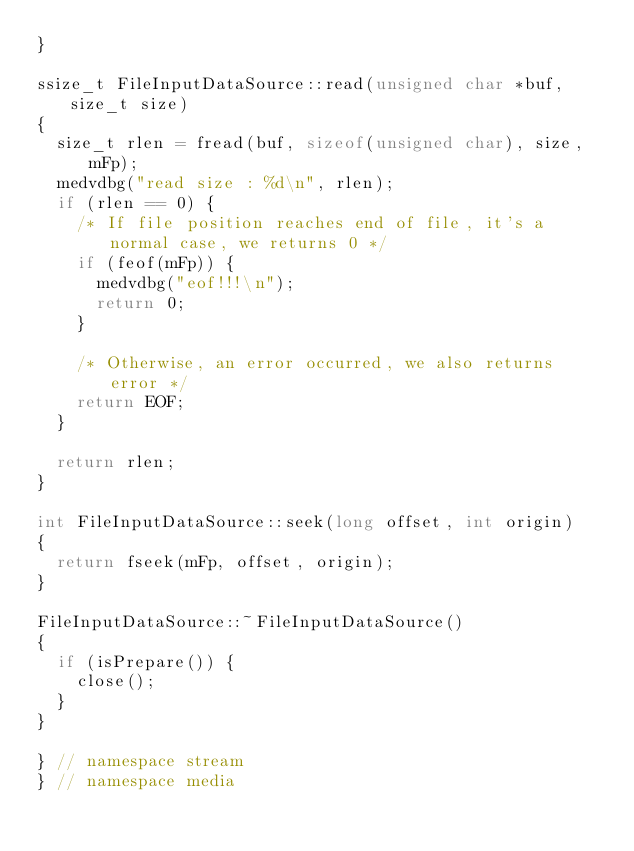<code> <loc_0><loc_0><loc_500><loc_500><_C++_>}

ssize_t FileInputDataSource::read(unsigned char *buf, size_t size)
{
	size_t rlen = fread(buf, sizeof(unsigned char), size, mFp);
	medvdbg("read size : %d\n", rlen);
	if (rlen == 0) {
		/* If file position reaches end of file, it's a normal case, we returns 0 */
		if (feof(mFp)) {
			medvdbg("eof!!!\n");
			return 0;
		}

		/* Otherwise, an error occurred, we also returns error */
		return EOF;
	}

	return rlen;
}

int FileInputDataSource::seek(long offset, int origin)
{
	return fseek(mFp, offset, origin);
}

FileInputDataSource::~FileInputDataSource()
{
	if (isPrepare()) {
		close();
	}
}

} // namespace stream
} // namespace media
</code> 